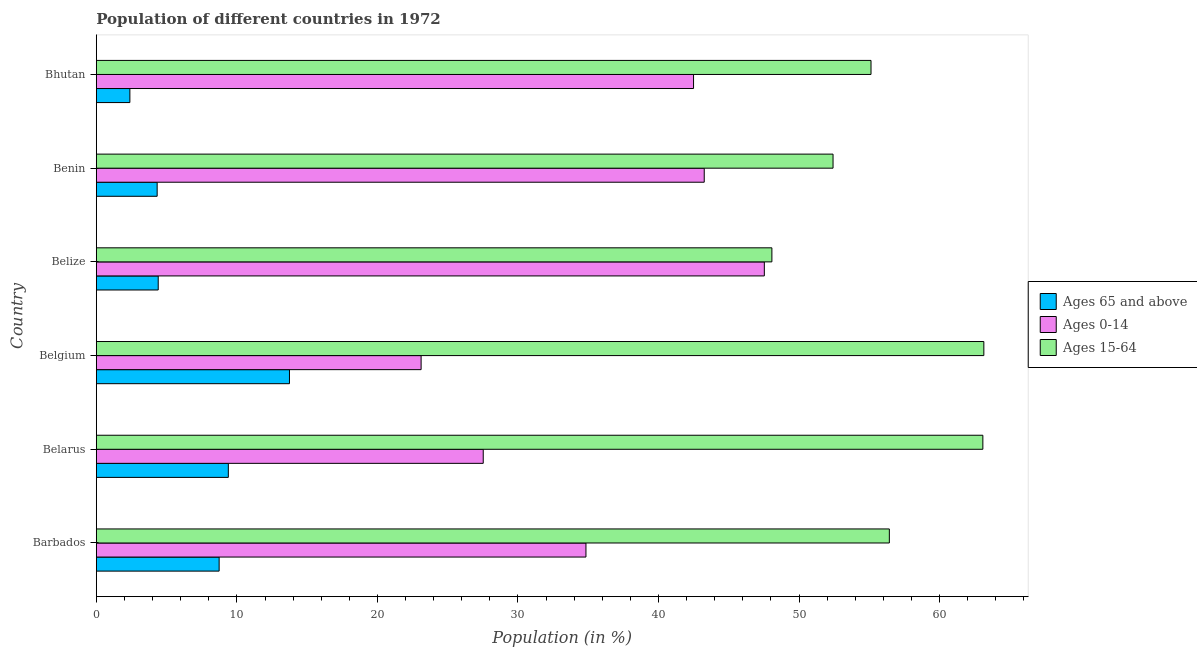How many different coloured bars are there?
Provide a short and direct response. 3. How many groups of bars are there?
Your answer should be compact. 6. Are the number of bars on each tick of the Y-axis equal?
Provide a succinct answer. Yes. How many bars are there on the 5th tick from the top?
Provide a short and direct response. 3. What is the label of the 3rd group of bars from the top?
Your response must be concise. Belize. In how many cases, is the number of bars for a given country not equal to the number of legend labels?
Your answer should be very brief. 0. What is the percentage of population within the age-group 15-64 in Belgium?
Provide a succinct answer. 63.15. Across all countries, what is the maximum percentage of population within the age-group of 65 and above?
Provide a succinct answer. 13.74. Across all countries, what is the minimum percentage of population within the age-group of 65 and above?
Provide a succinct answer. 2.39. In which country was the percentage of population within the age-group of 65 and above minimum?
Your response must be concise. Bhutan. What is the total percentage of population within the age-group 15-64 in the graph?
Your response must be concise. 338.26. What is the difference between the percentage of population within the age-group 0-14 in Belarus and that in Belize?
Give a very brief answer. -20. What is the difference between the percentage of population within the age-group 0-14 in Barbados and the percentage of population within the age-group of 65 and above in Belgium?
Your response must be concise. 21.1. What is the average percentage of population within the age-group 15-64 per country?
Offer a terse response. 56.38. What is the difference between the percentage of population within the age-group 15-64 and percentage of population within the age-group 0-14 in Belize?
Offer a very short reply. 0.54. In how many countries, is the percentage of population within the age-group 0-14 greater than 36 %?
Provide a short and direct response. 3. What is the ratio of the percentage of population within the age-group of 65 and above in Barbados to that in Belize?
Ensure brevity in your answer.  1.99. What is the difference between the highest and the second highest percentage of population within the age-group 15-64?
Make the answer very short. 0.07. What is the difference between the highest and the lowest percentage of population within the age-group 0-14?
Your answer should be compact. 24.42. What does the 1st bar from the top in Barbados represents?
Give a very brief answer. Ages 15-64. What does the 1st bar from the bottom in Benin represents?
Your response must be concise. Ages 65 and above. Is it the case that in every country, the sum of the percentage of population within the age-group of 65 and above and percentage of population within the age-group 0-14 is greater than the percentage of population within the age-group 15-64?
Ensure brevity in your answer.  No. How many bars are there?
Make the answer very short. 18. How many countries are there in the graph?
Provide a short and direct response. 6. Are the values on the major ticks of X-axis written in scientific E-notation?
Offer a very short reply. No. Does the graph contain any zero values?
Make the answer very short. No. Does the graph contain grids?
Provide a short and direct response. No. What is the title of the graph?
Give a very brief answer. Population of different countries in 1972. Does "Taxes" appear as one of the legend labels in the graph?
Offer a very short reply. No. What is the label or title of the X-axis?
Give a very brief answer. Population (in %). What is the label or title of the Y-axis?
Provide a succinct answer. Country. What is the Population (in %) in Ages 65 and above in Barbados?
Your answer should be very brief. 8.74. What is the Population (in %) of Ages 0-14 in Barbados?
Offer a terse response. 34.84. What is the Population (in %) of Ages 15-64 in Barbados?
Ensure brevity in your answer.  56.43. What is the Population (in %) in Ages 65 and above in Belarus?
Your answer should be very brief. 9.39. What is the Population (in %) in Ages 0-14 in Belarus?
Offer a very short reply. 27.53. What is the Population (in %) of Ages 15-64 in Belarus?
Offer a terse response. 63.08. What is the Population (in %) of Ages 65 and above in Belgium?
Make the answer very short. 13.74. What is the Population (in %) in Ages 0-14 in Belgium?
Ensure brevity in your answer.  23.11. What is the Population (in %) of Ages 15-64 in Belgium?
Provide a short and direct response. 63.15. What is the Population (in %) of Ages 65 and above in Belize?
Ensure brevity in your answer.  4.4. What is the Population (in %) of Ages 0-14 in Belize?
Make the answer very short. 47.53. What is the Population (in %) of Ages 15-64 in Belize?
Offer a very short reply. 48.07. What is the Population (in %) in Ages 65 and above in Benin?
Offer a terse response. 4.33. What is the Population (in %) of Ages 0-14 in Benin?
Make the answer very short. 43.25. What is the Population (in %) in Ages 15-64 in Benin?
Keep it short and to the point. 52.42. What is the Population (in %) in Ages 65 and above in Bhutan?
Your response must be concise. 2.39. What is the Population (in %) in Ages 0-14 in Bhutan?
Your answer should be very brief. 42.49. What is the Population (in %) of Ages 15-64 in Bhutan?
Make the answer very short. 55.12. Across all countries, what is the maximum Population (in %) of Ages 65 and above?
Give a very brief answer. 13.74. Across all countries, what is the maximum Population (in %) of Ages 0-14?
Keep it short and to the point. 47.53. Across all countries, what is the maximum Population (in %) in Ages 15-64?
Give a very brief answer. 63.15. Across all countries, what is the minimum Population (in %) in Ages 65 and above?
Provide a short and direct response. 2.39. Across all countries, what is the minimum Population (in %) in Ages 0-14?
Provide a short and direct response. 23.11. Across all countries, what is the minimum Population (in %) of Ages 15-64?
Provide a succinct answer. 48.07. What is the total Population (in %) in Ages 65 and above in the graph?
Your response must be concise. 42.98. What is the total Population (in %) of Ages 0-14 in the graph?
Keep it short and to the point. 218.75. What is the total Population (in %) in Ages 15-64 in the graph?
Offer a terse response. 338.26. What is the difference between the Population (in %) in Ages 65 and above in Barbados and that in Belarus?
Your response must be concise. -0.65. What is the difference between the Population (in %) in Ages 0-14 in Barbados and that in Belarus?
Offer a terse response. 7.31. What is the difference between the Population (in %) of Ages 15-64 in Barbados and that in Belarus?
Provide a succinct answer. -6.65. What is the difference between the Population (in %) of Ages 65 and above in Barbados and that in Belgium?
Keep it short and to the point. -5. What is the difference between the Population (in %) in Ages 0-14 in Barbados and that in Belgium?
Provide a succinct answer. 11.73. What is the difference between the Population (in %) in Ages 15-64 in Barbados and that in Belgium?
Provide a succinct answer. -6.72. What is the difference between the Population (in %) of Ages 65 and above in Barbados and that in Belize?
Your answer should be compact. 4.34. What is the difference between the Population (in %) of Ages 0-14 in Barbados and that in Belize?
Provide a short and direct response. -12.69. What is the difference between the Population (in %) of Ages 15-64 in Barbados and that in Belize?
Provide a succinct answer. 8.36. What is the difference between the Population (in %) in Ages 65 and above in Barbados and that in Benin?
Your response must be concise. 4.41. What is the difference between the Population (in %) of Ages 0-14 in Barbados and that in Benin?
Your response must be concise. -8.42. What is the difference between the Population (in %) of Ages 15-64 in Barbados and that in Benin?
Provide a succinct answer. 4.01. What is the difference between the Population (in %) of Ages 65 and above in Barbados and that in Bhutan?
Keep it short and to the point. 6.35. What is the difference between the Population (in %) of Ages 0-14 in Barbados and that in Bhutan?
Give a very brief answer. -7.66. What is the difference between the Population (in %) in Ages 15-64 in Barbados and that in Bhutan?
Your answer should be very brief. 1.3. What is the difference between the Population (in %) of Ages 65 and above in Belarus and that in Belgium?
Keep it short and to the point. -4.35. What is the difference between the Population (in %) in Ages 0-14 in Belarus and that in Belgium?
Keep it short and to the point. 4.42. What is the difference between the Population (in %) of Ages 15-64 in Belarus and that in Belgium?
Offer a terse response. -0.07. What is the difference between the Population (in %) of Ages 65 and above in Belarus and that in Belize?
Give a very brief answer. 4.99. What is the difference between the Population (in %) in Ages 0-14 in Belarus and that in Belize?
Your response must be concise. -20. What is the difference between the Population (in %) of Ages 15-64 in Belarus and that in Belize?
Your answer should be very brief. 15.01. What is the difference between the Population (in %) of Ages 65 and above in Belarus and that in Benin?
Give a very brief answer. 5.06. What is the difference between the Population (in %) in Ages 0-14 in Belarus and that in Benin?
Ensure brevity in your answer.  -15.72. What is the difference between the Population (in %) of Ages 15-64 in Belarus and that in Benin?
Your answer should be compact. 10.66. What is the difference between the Population (in %) of Ages 65 and above in Belarus and that in Bhutan?
Provide a succinct answer. 7.01. What is the difference between the Population (in %) in Ages 0-14 in Belarus and that in Bhutan?
Make the answer very short. -14.96. What is the difference between the Population (in %) of Ages 15-64 in Belarus and that in Bhutan?
Offer a terse response. 7.96. What is the difference between the Population (in %) in Ages 65 and above in Belgium and that in Belize?
Ensure brevity in your answer.  9.34. What is the difference between the Population (in %) of Ages 0-14 in Belgium and that in Belize?
Offer a very short reply. -24.42. What is the difference between the Population (in %) of Ages 15-64 in Belgium and that in Belize?
Keep it short and to the point. 15.08. What is the difference between the Population (in %) of Ages 65 and above in Belgium and that in Benin?
Give a very brief answer. 9.41. What is the difference between the Population (in %) in Ages 0-14 in Belgium and that in Benin?
Provide a short and direct response. -20.15. What is the difference between the Population (in %) of Ages 15-64 in Belgium and that in Benin?
Give a very brief answer. 10.73. What is the difference between the Population (in %) in Ages 65 and above in Belgium and that in Bhutan?
Provide a short and direct response. 11.36. What is the difference between the Population (in %) of Ages 0-14 in Belgium and that in Bhutan?
Ensure brevity in your answer.  -19.39. What is the difference between the Population (in %) of Ages 15-64 in Belgium and that in Bhutan?
Your answer should be very brief. 8.03. What is the difference between the Population (in %) of Ages 65 and above in Belize and that in Benin?
Offer a terse response. 0.07. What is the difference between the Population (in %) of Ages 0-14 in Belize and that in Benin?
Your answer should be compact. 4.28. What is the difference between the Population (in %) of Ages 15-64 in Belize and that in Benin?
Offer a very short reply. -4.35. What is the difference between the Population (in %) of Ages 65 and above in Belize and that in Bhutan?
Your answer should be very brief. 2.02. What is the difference between the Population (in %) of Ages 0-14 in Belize and that in Bhutan?
Provide a short and direct response. 5.04. What is the difference between the Population (in %) in Ages 15-64 in Belize and that in Bhutan?
Make the answer very short. -7.05. What is the difference between the Population (in %) in Ages 65 and above in Benin and that in Bhutan?
Ensure brevity in your answer.  1.94. What is the difference between the Population (in %) of Ages 0-14 in Benin and that in Bhutan?
Provide a succinct answer. 0.76. What is the difference between the Population (in %) of Ages 15-64 in Benin and that in Bhutan?
Ensure brevity in your answer.  -2.7. What is the difference between the Population (in %) in Ages 65 and above in Barbados and the Population (in %) in Ages 0-14 in Belarus?
Offer a very short reply. -18.79. What is the difference between the Population (in %) in Ages 65 and above in Barbados and the Population (in %) in Ages 15-64 in Belarus?
Ensure brevity in your answer.  -54.34. What is the difference between the Population (in %) in Ages 0-14 in Barbados and the Population (in %) in Ages 15-64 in Belarus?
Your response must be concise. -28.24. What is the difference between the Population (in %) of Ages 65 and above in Barbados and the Population (in %) of Ages 0-14 in Belgium?
Keep it short and to the point. -14.37. What is the difference between the Population (in %) of Ages 65 and above in Barbados and the Population (in %) of Ages 15-64 in Belgium?
Keep it short and to the point. -54.41. What is the difference between the Population (in %) in Ages 0-14 in Barbados and the Population (in %) in Ages 15-64 in Belgium?
Provide a succinct answer. -28.31. What is the difference between the Population (in %) of Ages 65 and above in Barbados and the Population (in %) of Ages 0-14 in Belize?
Give a very brief answer. -38.79. What is the difference between the Population (in %) in Ages 65 and above in Barbados and the Population (in %) in Ages 15-64 in Belize?
Make the answer very short. -39.33. What is the difference between the Population (in %) of Ages 0-14 in Barbados and the Population (in %) of Ages 15-64 in Belize?
Provide a short and direct response. -13.23. What is the difference between the Population (in %) in Ages 65 and above in Barbados and the Population (in %) in Ages 0-14 in Benin?
Your response must be concise. -34.52. What is the difference between the Population (in %) of Ages 65 and above in Barbados and the Population (in %) of Ages 15-64 in Benin?
Your response must be concise. -43.68. What is the difference between the Population (in %) in Ages 0-14 in Barbados and the Population (in %) in Ages 15-64 in Benin?
Offer a terse response. -17.58. What is the difference between the Population (in %) of Ages 65 and above in Barbados and the Population (in %) of Ages 0-14 in Bhutan?
Your answer should be very brief. -33.76. What is the difference between the Population (in %) of Ages 65 and above in Barbados and the Population (in %) of Ages 15-64 in Bhutan?
Your answer should be very brief. -46.38. What is the difference between the Population (in %) of Ages 0-14 in Barbados and the Population (in %) of Ages 15-64 in Bhutan?
Keep it short and to the point. -20.28. What is the difference between the Population (in %) of Ages 65 and above in Belarus and the Population (in %) of Ages 0-14 in Belgium?
Your response must be concise. -13.72. What is the difference between the Population (in %) of Ages 65 and above in Belarus and the Population (in %) of Ages 15-64 in Belgium?
Your answer should be very brief. -53.76. What is the difference between the Population (in %) in Ages 0-14 in Belarus and the Population (in %) in Ages 15-64 in Belgium?
Your answer should be very brief. -35.62. What is the difference between the Population (in %) in Ages 65 and above in Belarus and the Population (in %) in Ages 0-14 in Belize?
Keep it short and to the point. -38.14. What is the difference between the Population (in %) of Ages 65 and above in Belarus and the Population (in %) of Ages 15-64 in Belize?
Your answer should be compact. -38.68. What is the difference between the Population (in %) in Ages 0-14 in Belarus and the Population (in %) in Ages 15-64 in Belize?
Your response must be concise. -20.54. What is the difference between the Population (in %) in Ages 65 and above in Belarus and the Population (in %) in Ages 0-14 in Benin?
Your answer should be compact. -33.86. What is the difference between the Population (in %) of Ages 65 and above in Belarus and the Population (in %) of Ages 15-64 in Benin?
Ensure brevity in your answer.  -43.03. What is the difference between the Population (in %) of Ages 0-14 in Belarus and the Population (in %) of Ages 15-64 in Benin?
Give a very brief answer. -24.89. What is the difference between the Population (in %) in Ages 65 and above in Belarus and the Population (in %) in Ages 0-14 in Bhutan?
Make the answer very short. -33.1. What is the difference between the Population (in %) of Ages 65 and above in Belarus and the Population (in %) of Ages 15-64 in Bhutan?
Give a very brief answer. -45.73. What is the difference between the Population (in %) of Ages 0-14 in Belarus and the Population (in %) of Ages 15-64 in Bhutan?
Provide a succinct answer. -27.59. What is the difference between the Population (in %) of Ages 65 and above in Belgium and the Population (in %) of Ages 0-14 in Belize?
Ensure brevity in your answer.  -33.79. What is the difference between the Population (in %) of Ages 65 and above in Belgium and the Population (in %) of Ages 15-64 in Belize?
Your response must be concise. -34.33. What is the difference between the Population (in %) in Ages 0-14 in Belgium and the Population (in %) in Ages 15-64 in Belize?
Ensure brevity in your answer.  -24.96. What is the difference between the Population (in %) of Ages 65 and above in Belgium and the Population (in %) of Ages 0-14 in Benin?
Give a very brief answer. -29.51. What is the difference between the Population (in %) of Ages 65 and above in Belgium and the Population (in %) of Ages 15-64 in Benin?
Provide a short and direct response. -38.68. What is the difference between the Population (in %) in Ages 0-14 in Belgium and the Population (in %) in Ages 15-64 in Benin?
Your answer should be compact. -29.31. What is the difference between the Population (in %) in Ages 65 and above in Belgium and the Population (in %) in Ages 0-14 in Bhutan?
Your answer should be compact. -28.75. What is the difference between the Population (in %) in Ages 65 and above in Belgium and the Population (in %) in Ages 15-64 in Bhutan?
Your answer should be compact. -41.38. What is the difference between the Population (in %) of Ages 0-14 in Belgium and the Population (in %) of Ages 15-64 in Bhutan?
Your answer should be compact. -32.01. What is the difference between the Population (in %) of Ages 65 and above in Belize and the Population (in %) of Ages 0-14 in Benin?
Your response must be concise. -38.85. What is the difference between the Population (in %) of Ages 65 and above in Belize and the Population (in %) of Ages 15-64 in Benin?
Offer a terse response. -48.02. What is the difference between the Population (in %) in Ages 0-14 in Belize and the Population (in %) in Ages 15-64 in Benin?
Keep it short and to the point. -4.89. What is the difference between the Population (in %) of Ages 65 and above in Belize and the Population (in %) of Ages 0-14 in Bhutan?
Ensure brevity in your answer.  -38.09. What is the difference between the Population (in %) of Ages 65 and above in Belize and the Population (in %) of Ages 15-64 in Bhutan?
Your response must be concise. -50.72. What is the difference between the Population (in %) in Ages 0-14 in Belize and the Population (in %) in Ages 15-64 in Bhutan?
Offer a very short reply. -7.59. What is the difference between the Population (in %) in Ages 65 and above in Benin and the Population (in %) in Ages 0-14 in Bhutan?
Provide a succinct answer. -38.17. What is the difference between the Population (in %) of Ages 65 and above in Benin and the Population (in %) of Ages 15-64 in Bhutan?
Keep it short and to the point. -50.79. What is the difference between the Population (in %) of Ages 0-14 in Benin and the Population (in %) of Ages 15-64 in Bhutan?
Provide a succinct answer. -11.87. What is the average Population (in %) in Ages 65 and above per country?
Ensure brevity in your answer.  7.16. What is the average Population (in %) of Ages 0-14 per country?
Offer a terse response. 36.46. What is the average Population (in %) of Ages 15-64 per country?
Offer a very short reply. 56.38. What is the difference between the Population (in %) of Ages 65 and above and Population (in %) of Ages 0-14 in Barbados?
Make the answer very short. -26.1. What is the difference between the Population (in %) of Ages 65 and above and Population (in %) of Ages 15-64 in Barbados?
Provide a succinct answer. -47.69. What is the difference between the Population (in %) in Ages 0-14 and Population (in %) in Ages 15-64 in Barbados?
Your response must be concise. -21.59. What is the difference between the Population (in %) in Ages 65 and above and Population (in %) in Ages 0-14 in Belarus?
Your answer should be compact. -18.14. What is the difference between the Population (in %) of Ages 65 and above and Population (in %) of Ages 15-64 in Belarus?
Your answer should be very brief. -53.69. What is the difference between the Population (in %) of Ages 0-14 and Population (in %) of Ages 15-64 in Belarus?
Offer a very short reply. -35.55. What is the difference between the Population (in %) of Ages 65 and above and Population (in %) of Ages 0-14 in Belgium?
Your answer should be very brief. -9.37. What is the difference between the Population (in %) of Ages 65 and above and Population (in %) of Ages 15-64 in Belgium?
Your answer should be compact. -49.41. What is the difference between the Population (in %) in Ages 0-14 and Population (in %) in Ages 15-64 in Belgium?
Your answer should be compact. -40.04. What is the difference between the Population (in %) in Ages 65 and above and Population (in %) in Ages 0-14 in Belize?
Your response must be concise. -43.13. What is the difference between the Population (in %) in Ages 65 and above and Population (in %) in Ages 15-64 in Belize?
Offer a very short reply. -43.67. What is the difference between the Population (in %) of Ages 0-14 and Population (in %) of Ages 15-64 in Belize?
Make the answer very short. -0.54. What is the difference between the Population (in %) in Ages 65 and above and Population (in %) in Ages 0-14 in Benin?
Make the answer very short. -38.93. What is the difference between the Population (in %) in Ages 65 and above and Population (in %) in Ages 15-64 in Benin?
Provide a succinct answer. -48.09. What is the difference between the Population (in %) of Ages 0-14 and Population (in %) of Ages 15-64 in Benin?
Offer a terse response. -9.17. What is the difference between the Population (in %) in Ages 65 and above and Population (in %) in Ages 0-14 in Bhutan?
Keep it short and to the point. -40.11. What is the difference between the Population (in %) in Ages 65 and above and Population (in %) in Ages 15-64 in Bhutan?
Your response must be concise. -52.74. What is the difference between the Population (in %) in Ages 0-14 and Population (in %) in Ages 15-64 in Bhutan?
Provide a succinct answer. -12.63. What is the ratio of the Population (in %) in Ages 65 and above in Barbados to that in Belarus?
Make the answer very short. 0.93. What is the ratio of the Population (in %) in Ages 0-14 in Barbados to that in Belarus?
Make the answer very short. 1.27. What is the ratio of the Population (in %) of Ages 15-64 in Barbados to that in Belarus?
Offer a terse response. 0.89. What is the ratio of the Population (in %) in Ages 65 and above in Barbados to that in Belgium?
Provide a succinct answer. 0.64. What is the ratio of the Population (in %) of Ages 0-14 in Barbados to that in Belgium?
Provide a succinct answer. 1.51. What is the ratio of the Population (in %) of Ages 15-64 in Barbados to that in Belgium?
Keep it short and to the point. 0.89. What is the ratio of the Population (in %) of Ages 65 and above in Barbados to that in Belize?
Make the answer very short. 1.98. What is the ratio of the Population (in %) of Ages 0-14 in Barbados to that in Belize?
Make the answer very short. 0.73. What is the ratio of the Population (in %) in Ages 15-64 in Barbados to that in Belize?
Give a very brief answer. 1.17. What is the ratio of the Population (in %) of Ages 65 and above in Barbados to that in Benin?
Offer a terse response. 2.02. What is the ratio of the Population (in %) of Ages 0-14 in Barbados to that in Benin?
Offer a very short reply. 0.81. What is the ratio of the Population (in %) in Ages 15-64 in Barbados to that in Benin?
Provide a short and direct response. 1.08. What is the ratio of the Population (in %) of Ages 65 and above in Barbados to that in Bhutan?
Your answer should be very brief. 3.66. What is the ratio of the Population (in %) of Ages 0-14 in Barbados to that in Bhutan?
Your answer should be very brief. 0.82. What is the ratio of the Population (in %) in Ages 15-64 in Barbados to that in Bhutan?
Provide a succinct answer. 1.02. What is the ratio of the Population (in %) of Ages 65 and above in Belarus to that in Belgium?
Offer a terse response. 0.68. What is the ratio of the Population (in %) in Ages 0-14 in Belarus to that in Belgium?
Your response must be concise. 1.19. What is the ratio of the Population (in %) of Ages 15-64 in Belarus to that in Belgium?
Your answer should be compact. 1. What is the ratio of the Population (in %) in Ages 65 and above in Belarus to that in Belize?
Make the answer very short. 2.13. What is the ratio of the Population (in %) of Ages 0-14 in Belarus to that in Belize?
Provide a short and direct response. 0.58. What is the ratio of the Population (in %) of Ages 15-64 in Belarus to that in Belize?
Offer a very short reply. 1.31. What is the ratio of the Population (in %) of Ages 65 and above in Belarus to that in Benin?
Your answer should be compact. 2.17. What is the ratio of the Population (in %) of Ages 0-14 in Belarus to that in Benin?
Offer a very short reply. 0.64. What is the ratio of the Population (in %) in Ages 15-64 in Belarus to that in Benin?
Give a very brief answer. 1.2. What is the ratio of the Population (in %) of Ages 65 and above in Belarus to that in Bhutan?
Give a very brief answer. 3.94. What is the ratio of the Population (in %) in Ages 0-14 in Belarus to that in Bhutan?
Offer a terse response. 0.65. What is the ratio of the Population (in %) in Ages 15-64 in Belarus to that in Bhutan?
Offer a terse response. 1.14. What is the ratio of the Population (in %) of Ages 65 and above in Belgium to that in Belize?
Offer a terse response. 3.12. What is the ratio of the Population (in %) in Ages 0-14 in Belgium to that in Belize?
Your answer should be compact. 0.49. What is the ratio of the Population (in %) of Ages 15-64 in Belgium to that in Belize?
Give a very brief answer. 1.31. What is the ratio of the Population (in %) of Ages 65 and above in Belgium to that in Benin?
Give a very brief answer. 3.18. What is the ratio of the Population (in %) of Ages 0-14 in Belgium to that in Benin?
Make the answer very short. 0.53. What is the ratio of the Population (in %) of Ages 15-64 in Belgium to that in Benin?
Your answer should be compact. 1.2. What is the ratio of the Population (in %) of Ages 65 and above in Belgium to that in Bhutan?
Your response must be concise. 5.76. What is the ratio of the Population (in %) in Ages 0-14 in Belgium to that in Bhutan?
Your response must be concise. 0.54. What is the ratio of the Population (in %) of Ages 15-64 in Belgium to that in Bhutan?
Your response must be concise. 1.15. What is the ratio of the Population (in %) of Ages 65 and above in Belize to that in Benin?
Your response must be concise. 1.02. What is the ratio of the Population (in %) in Ages 0-14 in Belize to that in Benin?
Make the answer very short. 1.1. What is the ratio of the Population (in %) in Ages 15-64 in Belize to that in Benin?
Offer a terse response. 0.92. What is the ratio of the Population (in %) in Ages 65 and above in Belize to that in Bhutan?
Your answer should be very brief. 1.85. What is the ratio of the Population (in %) of Ages 0-14 in Belize to that in Bhutan?
Ensure brevity in your answer.  1.12. What is the ratio of the Population (in %) in Ages 15-64 in Belize to that in Bhutan?
Offer a very short reply. 0.87. What is the ratio of the Population (in %) of Ages 65 and above in Benin to that in Bhutan?
Your response must be concise. 1.81. What is the ratio of the Population (in %) in Ages 0-14 in Benin to that in Bhutan?
Your response must be concise. 1.02. What is the ratio of the Population (in %) of Ages 15-64 in Benin to that in Bhutan?
Make the answer very short. 0.95. What is the difference between the highest and the second highest Population (in %) of Ages 65 and above?
Give a very brief answer. 4.35. What is the difference between the highest and the second highest Population (in %) of Ages 0-14?
Offer a terse response. 4.28. What is the difference between the highest and the second highest Population (in %) in Ages 15-64?
Make the answer very short. 0.07. What is the difference between the highest and the lowest Population (in %) of Ages 65 and above?
Make the answer very short. 11.36. What is the difference between the highest and the lowest Population (in %) in Ages 0-14?
Provide a short and direct response. 24.42. What is the difference between the highest and the lowest Population (in %) in Ages 15-64?
Offer a very short reply. 15.08. 